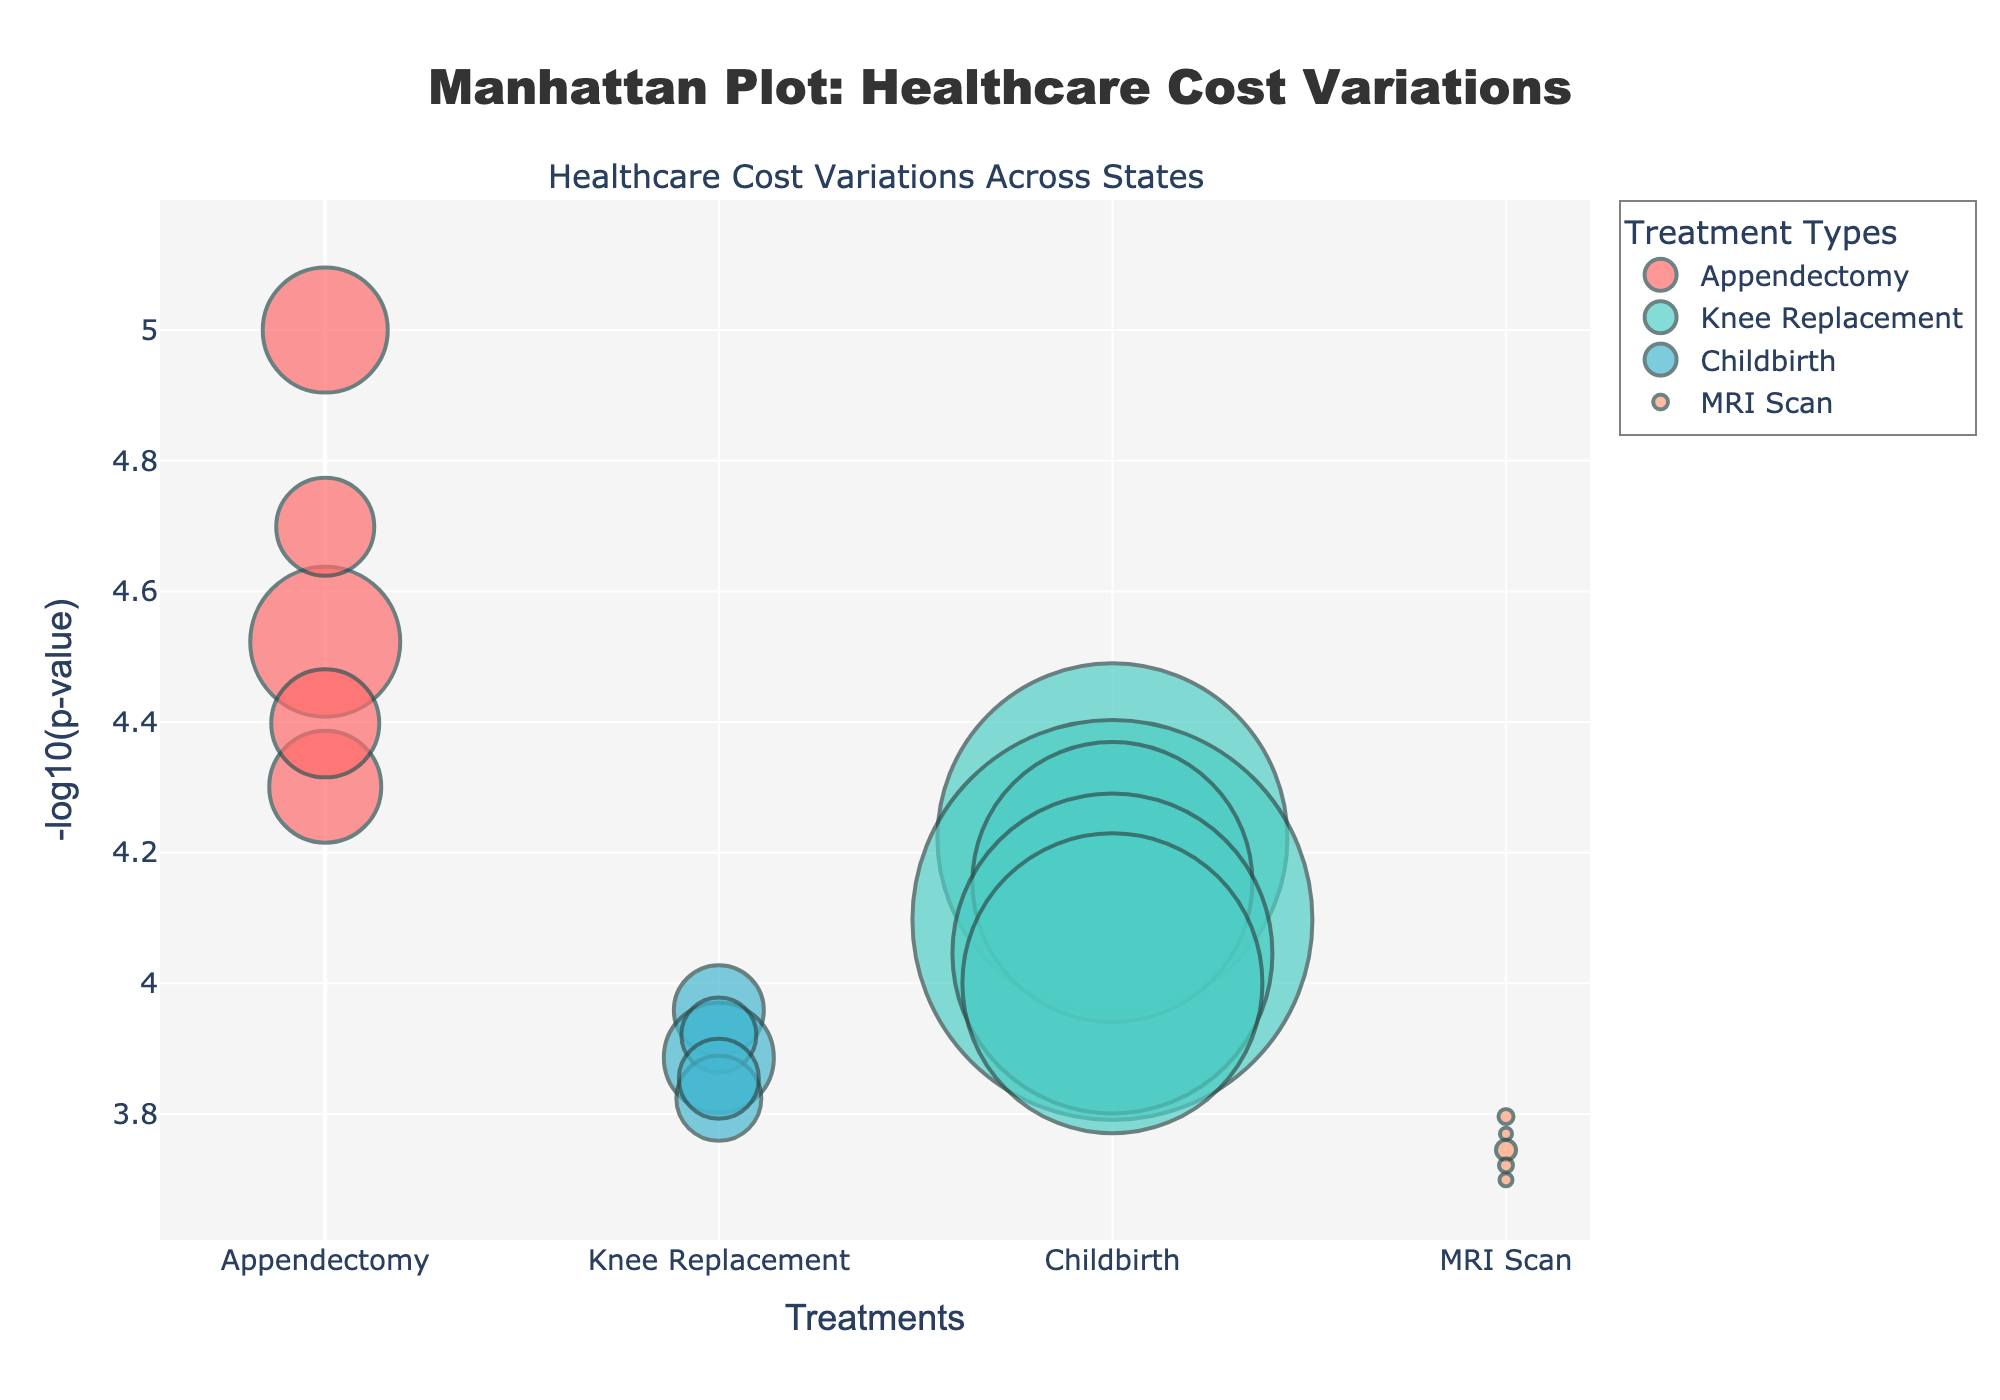What are the treatments represented in the plot? The plot represents four treatments as described in the divisions on the x-axis. These treatments are Appendectomy, Knee Replacement, Childbirth, and MRI Scan.
Answer: Appendectomy, Knee Replacement, Childbirth, MRI Scan Which state has the highest treatment cost for Appendectomy? By examining the plot, each treatment can be identified by its unique color and how the hover information reveals cost details. The highest cost for Appendectomy is found in California, $15,000.
Answer: California What is the -log10(p-value) for MRI Scan in Florida? Locate the MRI Scan data points and find the one for Florida by hovering or cross-referencing the position, which then shows a value around 4.72 in the y-axis.
Answer: ~4.72 What is the range of treatment costs for Childbirth in the states displayed? By checking each of the data points for Childbirth across the displayed states, the costs range from $7,500 (Texas) to $11,000 (California).
Answer: $7,500 to $11,000 Compare the costs of Knee Replacement between New York and Texas. Which is higher? By checking the Knee Replacement data points, the cost for New York is $35,000, and for Texas, it is $28,000. Thus, New York is higher.
Answer: New York If you average the cost of Appendectomy across all states, what is the average cost? Sum the costs of Appendectomy [12500 (NY) + 15000 (CA) + 9800 (TX) + 11200 (FL) + 10800 (IL)] = $59300. Divide by the number of states (5): $59300/5 = $11,860.
Answer: $11,860 Which treatment has the lowest average -log10(p-value)? Calculate the average -log10(p-value) for each treatment; Appendectomy (5 points), Knee Replacement (5 points), Childbirth (5 points), MRI Scan (5 points). MRI Scan has consistently higher p-values, resulting in a lower -log10(p-value).
Answer: MRI Scan What is the total number of data points shown in the plot? Each treatment is represented by a data point for each state, with 4 treatments and 5 states, leading to 4 * 5 = 20 data points.
Answer: 20 Which state shows the lowest -log10(p-value) for any treatment? Check all data points for the lowest position on the y-axis, which appears to be Childbirth in New York with -log10(p-value) around 3.95.
Answer: New York 